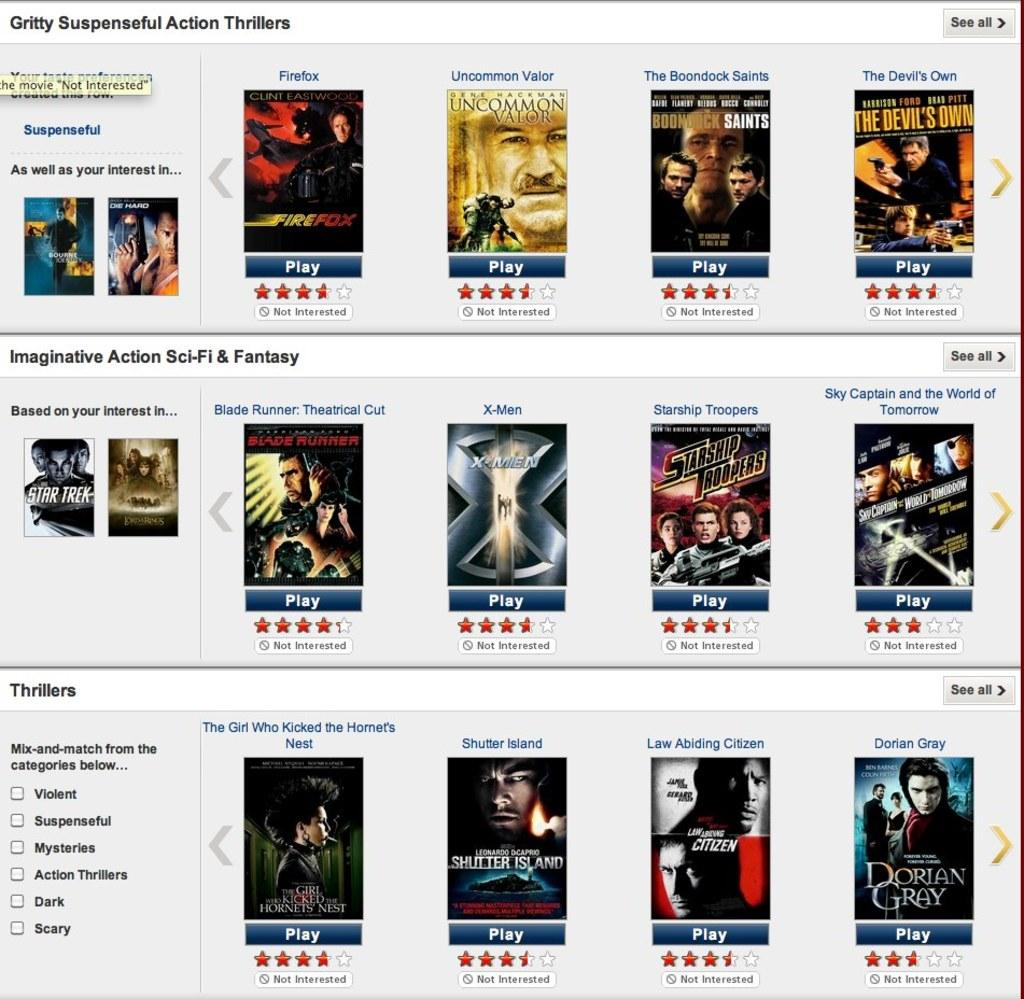Provide a one-sentence caption for the provided image. A screen shot of many movie title such as The Devil's Own. 